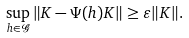Convert formula to latex. <formula><loc_0><loc_0><loc_500><loc_500>\sup _ { h \in \mathcal { G } } \| K - \Psi ( h ) K \| \geq \varepsilon \| K \| .</formula> 